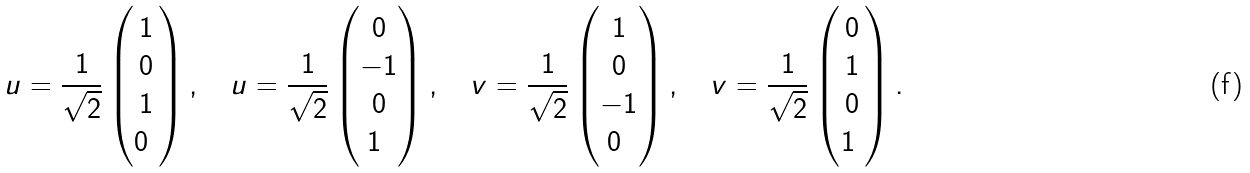<formula> <loc_0><loc_0><loc_500><loc_500>u ^ { } = \frac { 1 } { \sqrt { 2 } } \begin{pmatrix} 1 \\ 0 \\ 1 \\ 0 \ \end{pmatrix} , \quad u ^ { } = \frac { 1 } { \sqrt { 2 } } \begin{pmatrix} 0 \\ - 1 \\ 0 \\ 1 \ \end{pmatrix} , \quad v ^ { } = \frac { 1 } { \sqrt { 2 } } \begin{pmatrix} 1 \\ 0 \\ - 1 \\ 0 \ \end{pmatrix} , \quad v ^ { } = \frac { 1 } { \sqrt { 2 } } \begin{pmatrix} 0 \\ 1 \\ 0 \\ 1 \ \end{pmatrix} .</formula> 